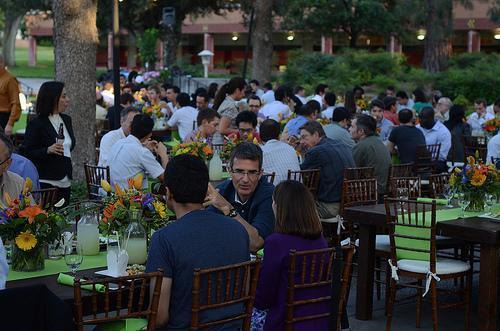How many people are standing?
Give a very brief answer. 2. 